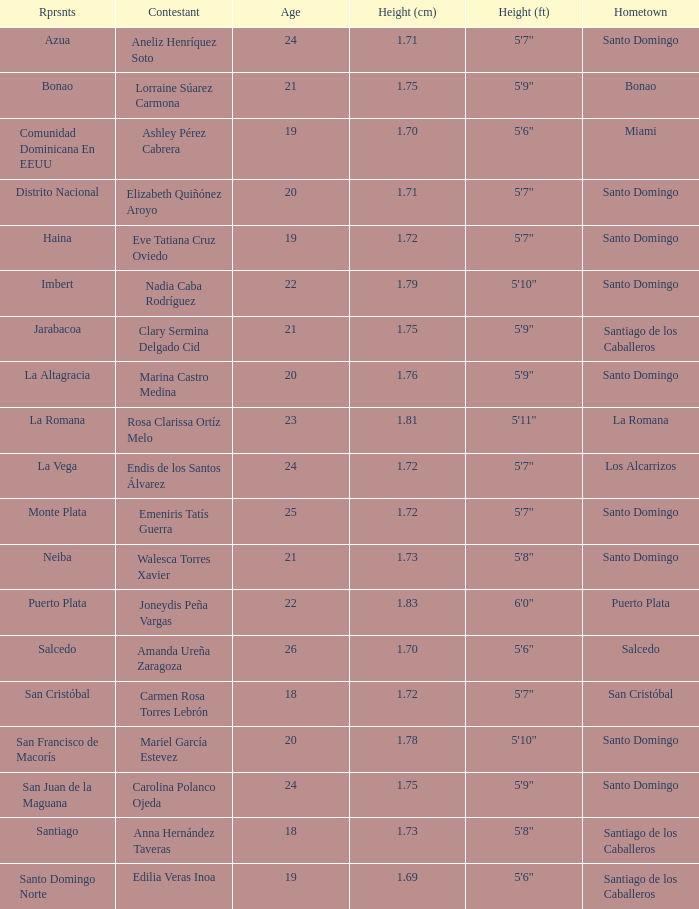Name the total number of represents for clary sermina delgado cid 1.0. 